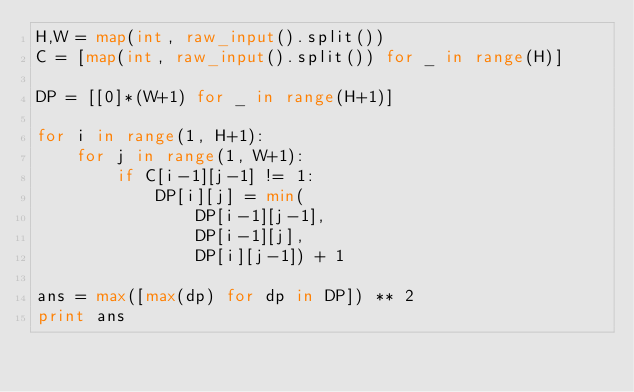Convert code to text. <code><loc_0><loc_0><loc_500><loc_500><_Python_>H,W = map(int, raw_input().split())
C = [map(int, raw_input().split()) for _ in range(H)]

DP = [[0]*(W+1) for _ in range(H+1)]

for i in range(1, H+1):
    for j in range(1, W+1):
        if C[i-1][j-1] != 1:
            DP[i][j] = min(
                DP[i-1][j-1],
                DP[i-1][j],
                DP[i][j-1]) + 1

ans = max([max(dp) for dp in DP]) ** 2
print ans
</code> 